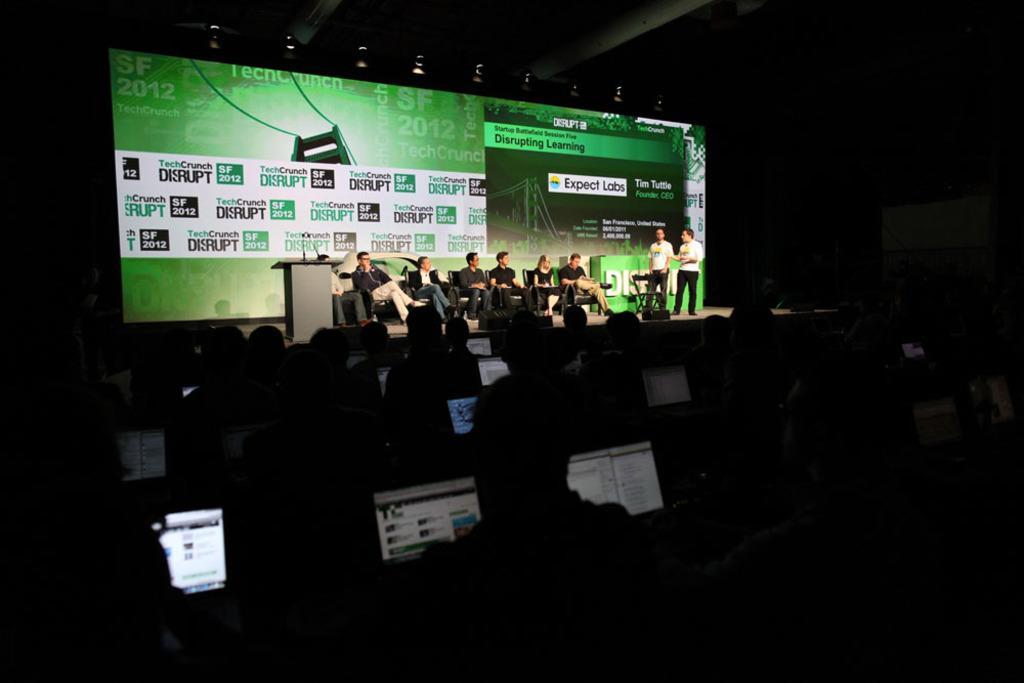Describe this image in one or two sentences. As we can see in the image there are screens, chairs, group of people and mics. The image is little dark. 